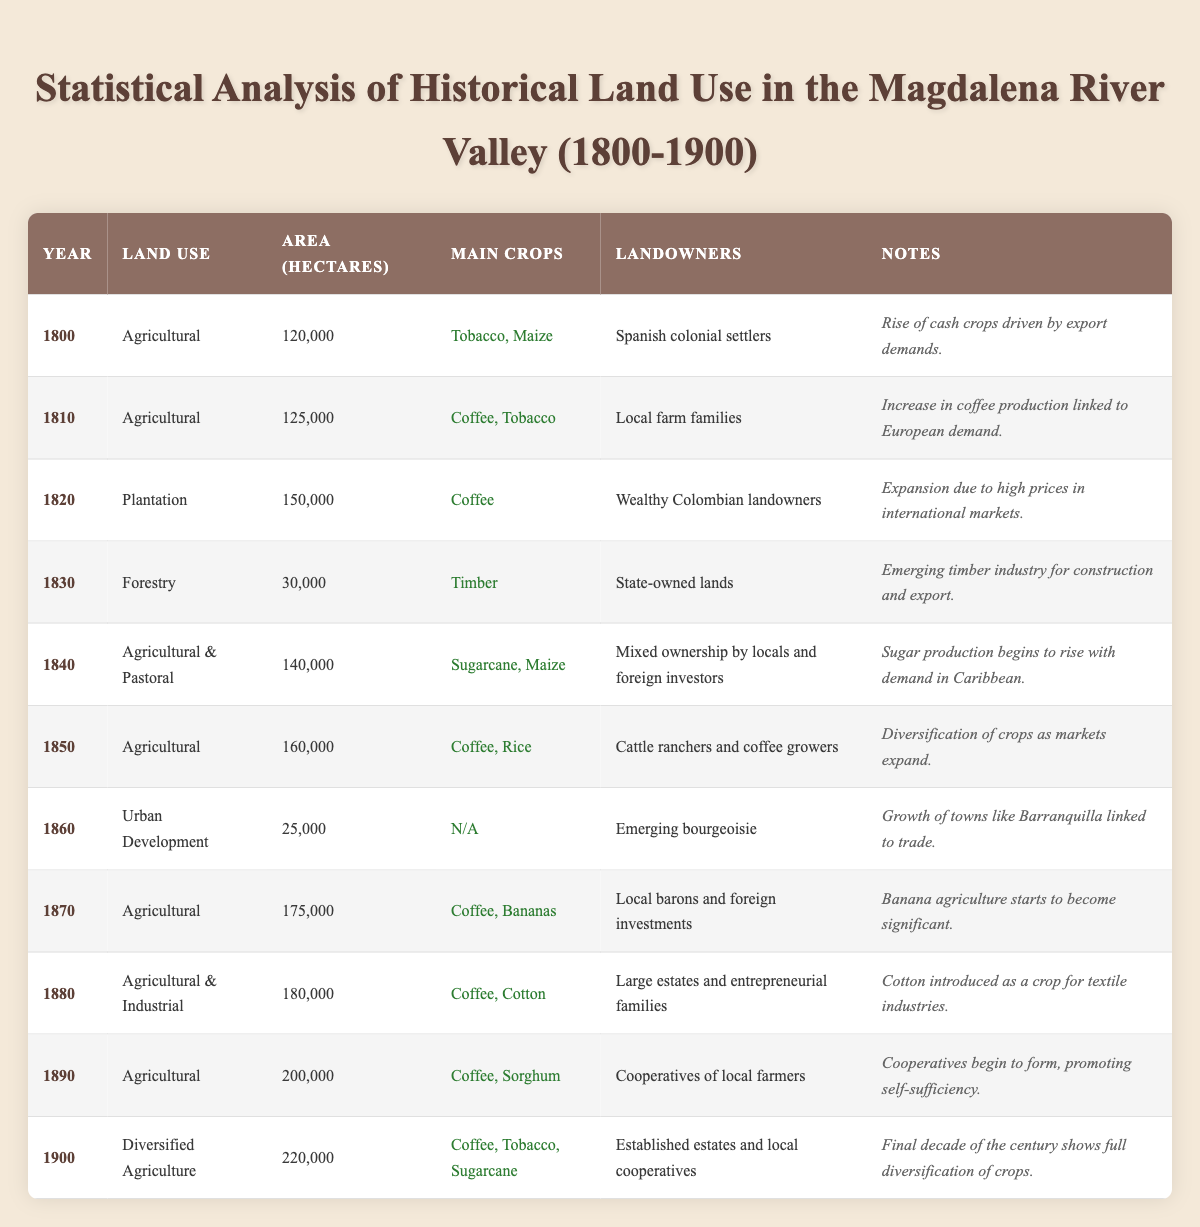What was the primary land use in the year 1820? The table indicates that in 1820, the land use type was "Plantation."
Answer: Plantation How many hectares of land were used for urban development in 1860? According to the table, the area designated for urban development in 1860 was 25,000 hectares.
Answer: 25,000 Which year saw the highest recorded area for agricultural land use, and what was that area? In 1900, the table shows that agricultural land use reached the highest area of 220,000 hectares.
Answer: 1900, 220,000 Is it true that sugarcane was the primary crop in 1840? The table indicates that sugarcane was one of the main crops in 1840, along with maize, therefore the statement is true.
Answer: True What was the trend in land use from 1800 to 1900 regarding the area in hectares? Examining the table, one can see an overall increase from 120,000 hectares to 220,000 hectares over the century, indicating a growth trend in land use.
Answer: Increasing What is the combined area of land used for agriculture during the years 1800, 1810, and 1850? Summing the areas of these years gives: 120,000 (1800) + 125,000 (1810) + 160,000 (1850) = 405,000 hectares total.
Answer: 405,000 In what year did local farm families begin to dominate land ownership, and what was the main crop produced? The table reveals that local farm families became predominant landowners in 1810 and the main crops were coffee and tobacco.
Answer: 1810, Coffee and Tobacco What was the change in land use type from 1860 to 1870? The table shows a transition from "Urban Development" in 1860 to "Agricultural" in 1870. This indicates a shift back toward agricultural uses.
Answer: Urban Development to Agricultural How many hectares of land were used for forestry in 1830 compared to agricultural land in 1840? In 1830, 30,000 hectares were used for forestry and in 1840, 140,000 hectares were used for agricultural purposes, a difference of 110,000 hectares more for agriculture.
Answer: 110,000 more for agriculture What was the notable development in the year 1880, in terms of land use? The table indicates that in 1880, the land use type was "Agricultural & Industrial," marking a significant diversification as cotton was introduced.
Answer: Agricultural & Industrial; cotton introduced List the main crops cultivated in 1900 and compare this with the main crops in 1820. In 1900, the main crops were coffee, tobacco, and sugarcane, whereas in 1820, only coffee was the main crop. This indicates a significant diversification over the years.
Answer: Coffee, Tobacco, Sugarcane; more diversified than in 1820 